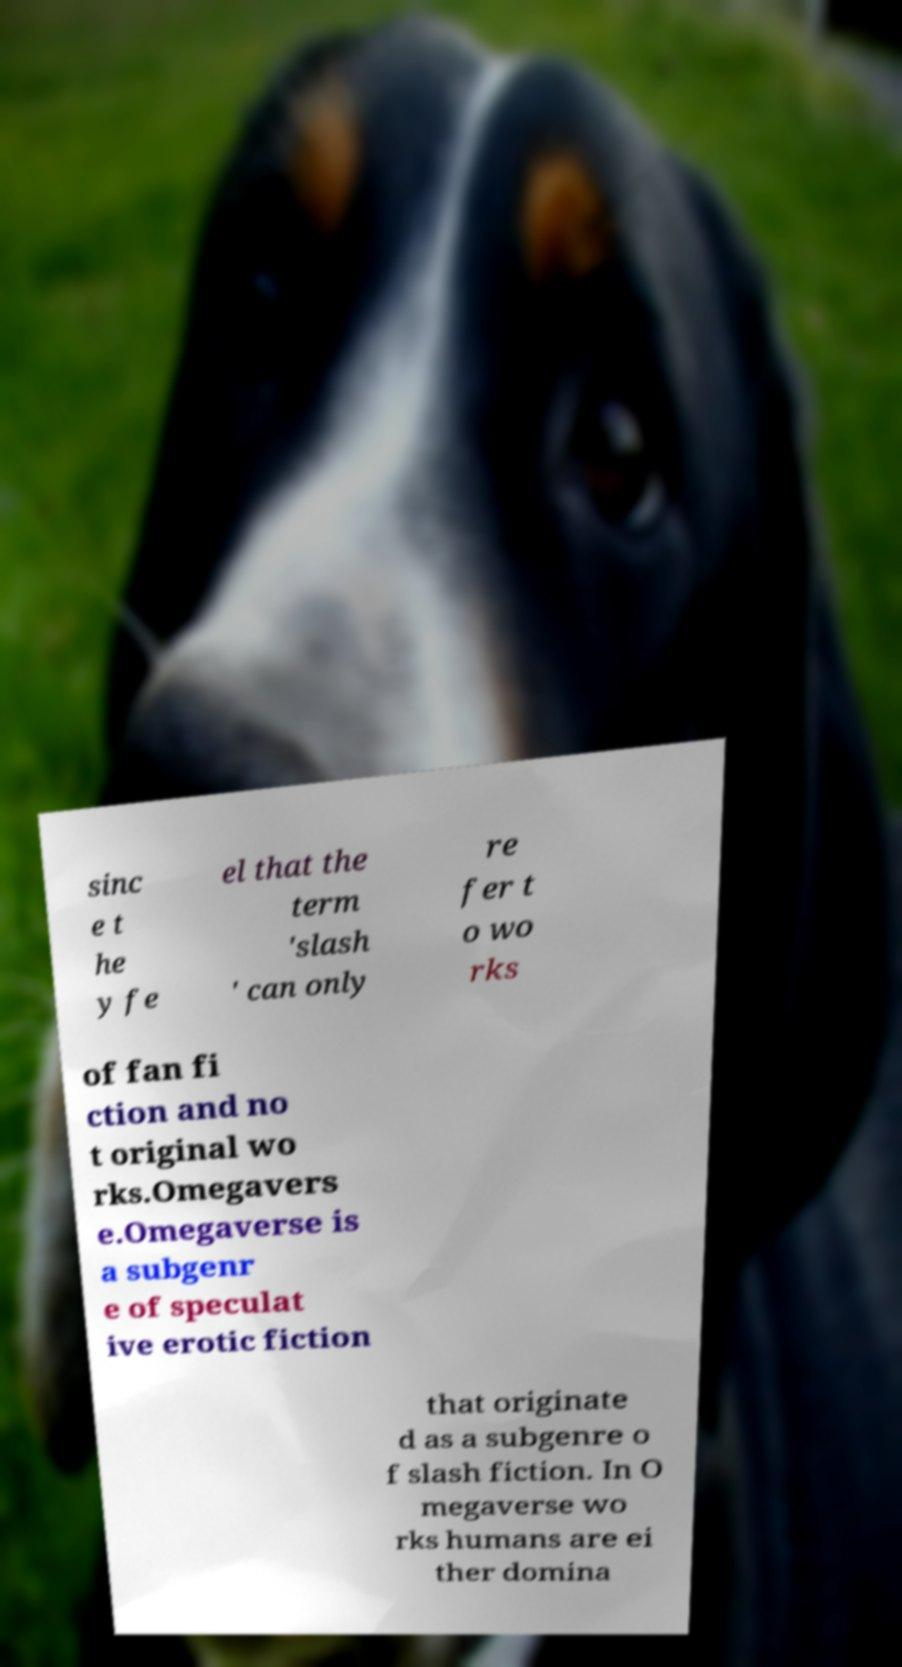I need the written content from this picture converted into text. Can you do that? sinc e t he y fe el that the term 'slash ' can only re fer t o wo rks of fan fi ction and no t original wo rks.Omegavers e.Omegaverse is a subgenr e of speculat ive erotic fiction that originate d as a subgenre o f slash fiction. In O megaverse wo rks humans are ei ther domina 